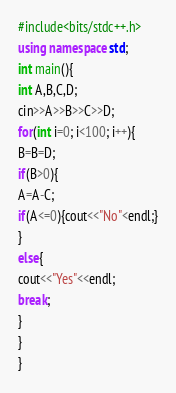<code> <loc_0><loc_0><loc_500><loc_500><_C++_>#include<bits/stdc++.h>
using namespace std;
int main(){
int A,B,C,D;
cin>>A>>B>>C>>D;
for(int i=0; i<100; i++){
B=B=D;
if(B>0){
A=A-C;
if(A<=0){cout<<"No"<endl;}
}
else{
cout<<"Yes"<<endl;
break;
}
}
}

</code> 